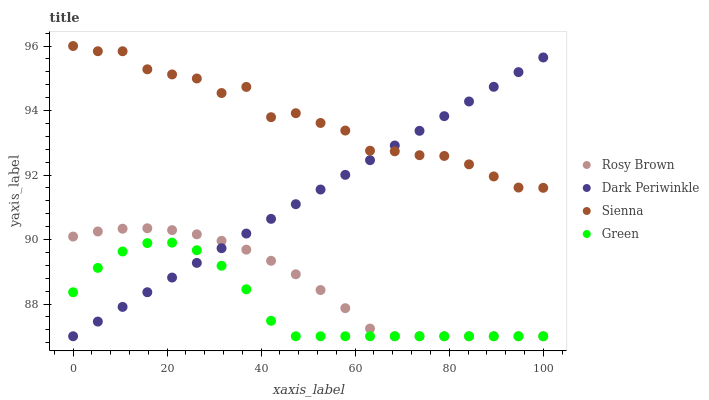Does Green have the minimum area under the curve?
Answer yes or no. Yes. Does Sienna have the maximum area under the curve?
Answer yes or no. Yes. Does Rosy Brown have the minimum area under the curve?
Answer yes or no. No. Does Rosy Brown have the maximum area under the curve?
Answer yes or no. No. Is Dark Periwinkle the smoothest?
Answer yes or no. Yes. Is Sienna the roughest?
Answer yes or no. Yes. Is Rosy Brown the smoothest?
Answer yes or no. No. Is Rosy Brown the roughest?
Answer yes or no. No. Does Rosy Brown have the lowest value?
Answer yes or no. Yes. Does Sienna have the highest value?
Answer yes or no. Yes. Does Rosy Brown have the highest value?
Answer yes or no. No. Is Rosy Brown less than Sienna?
Answer yes or no. Yes. Is Sienna greater than Rosy Brown?
Answer yes or no. Yes. Does Green intersect Rosy Brown?
Answer yes or no. Yes. Is Green less than Rosy Brown?
Answer yes or no. No. Is Green greater than Rosy Brown?
Answer yes or no. No. Does Rosy Brown intersect Sienna?
Answer yes or no. No. 